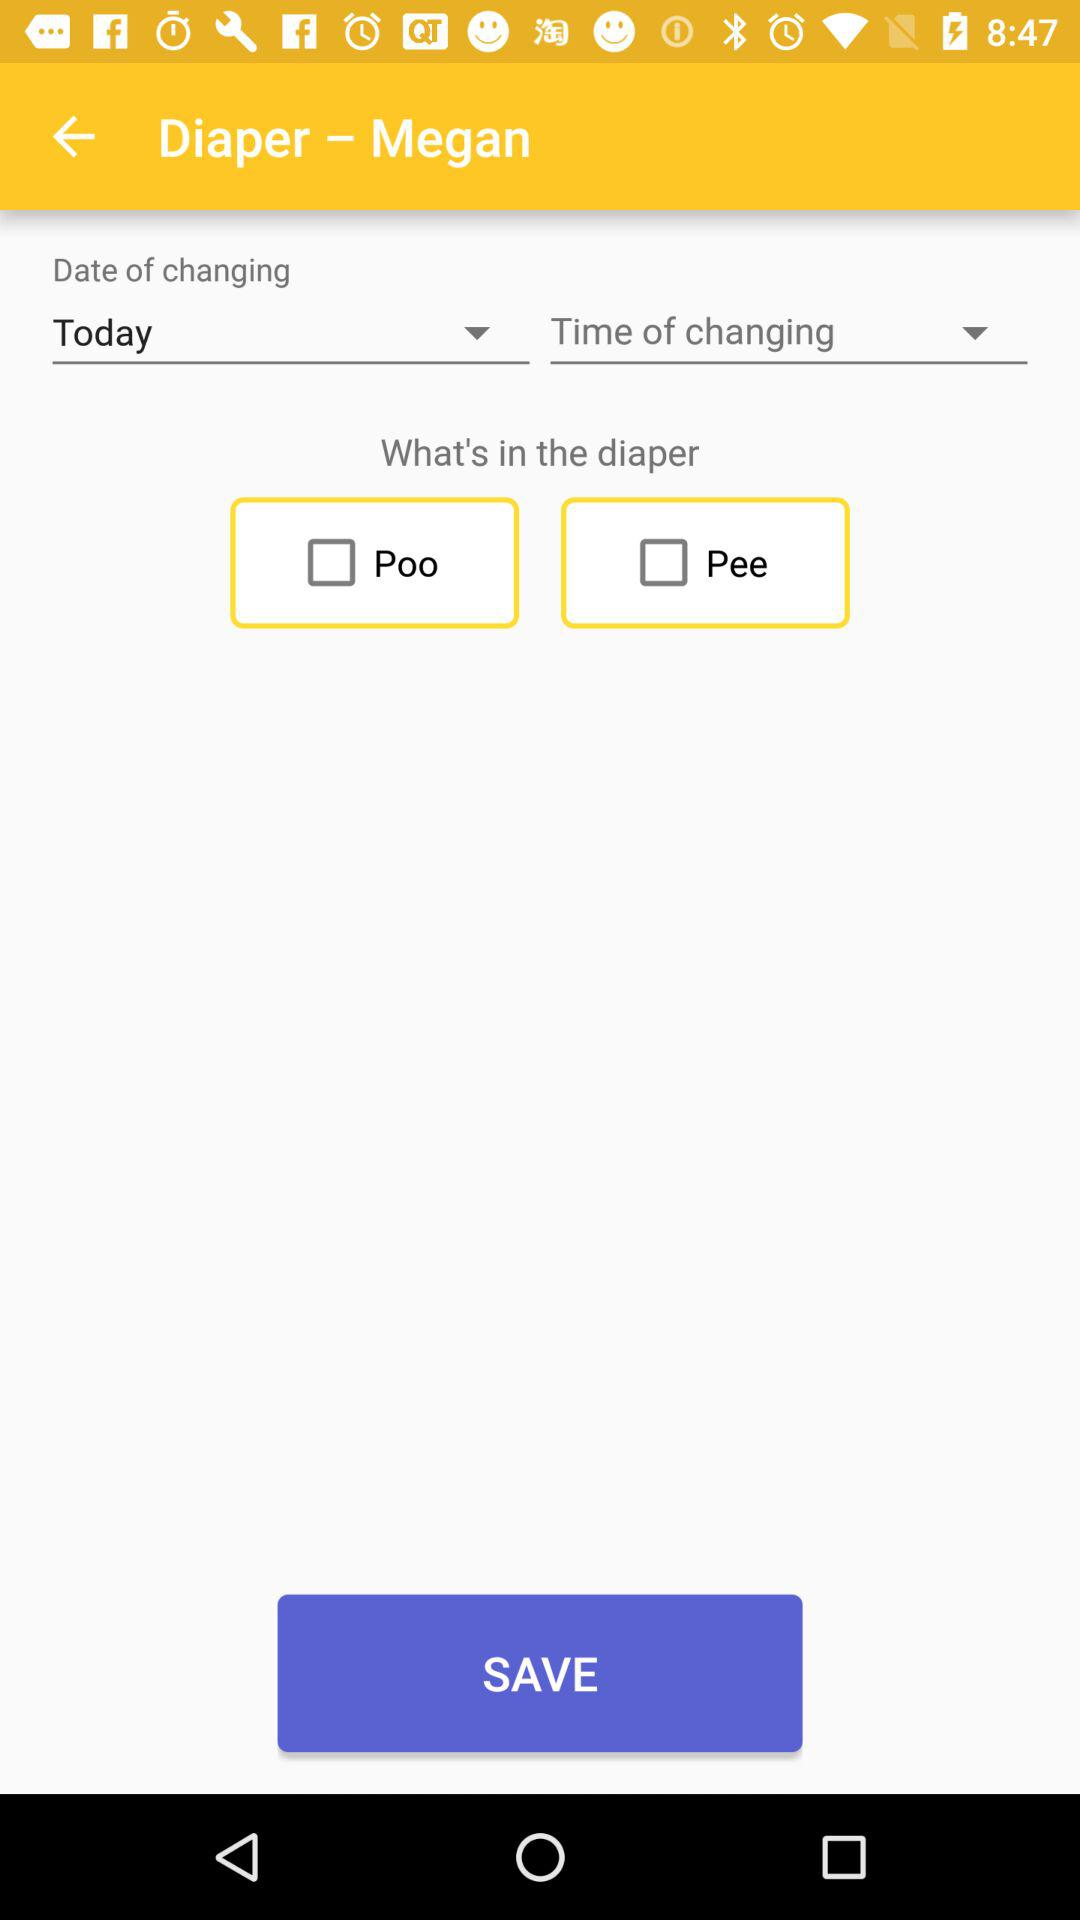What is the status of "Poo"? The status of "Poo" is "off". 